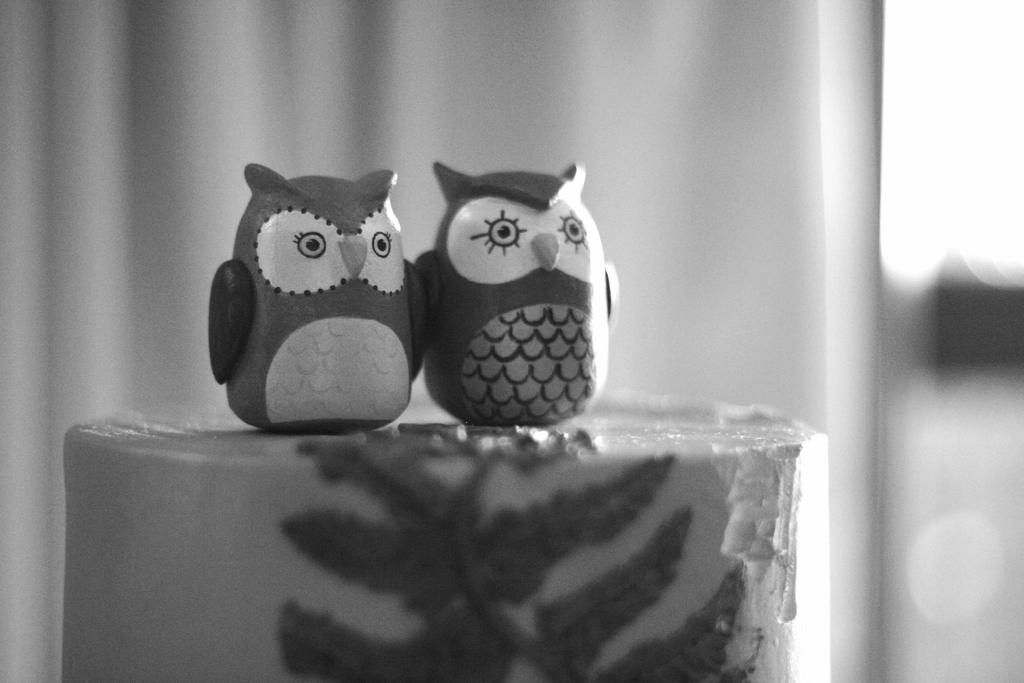What is the color scheme of the image? The image is black and white. What objects can be seen in the image? There are 2 owl toys in the image. Can you describe the background of the image? The background is blurred. How many children are playing with the owl toys in the image? There are no children present in the image; it only features 2 owl toys. What is the weight of the air in the image? The weight of air cannot be determined from the image, as it is a concept that cannot be visually represented. 